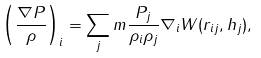Convert formula to latex. <formula><loc_0><loc_0><loc_500><loc_500>\left ( \frac { \nabla P } { \rho } \right ) _ { i } = \sum _ { j } m \frac { P _ { j } } { \rho _ { i } \rho _ { j } } \nabla _ { i } W ( r _ { i j } , h _ { j } ) ,</formula> 